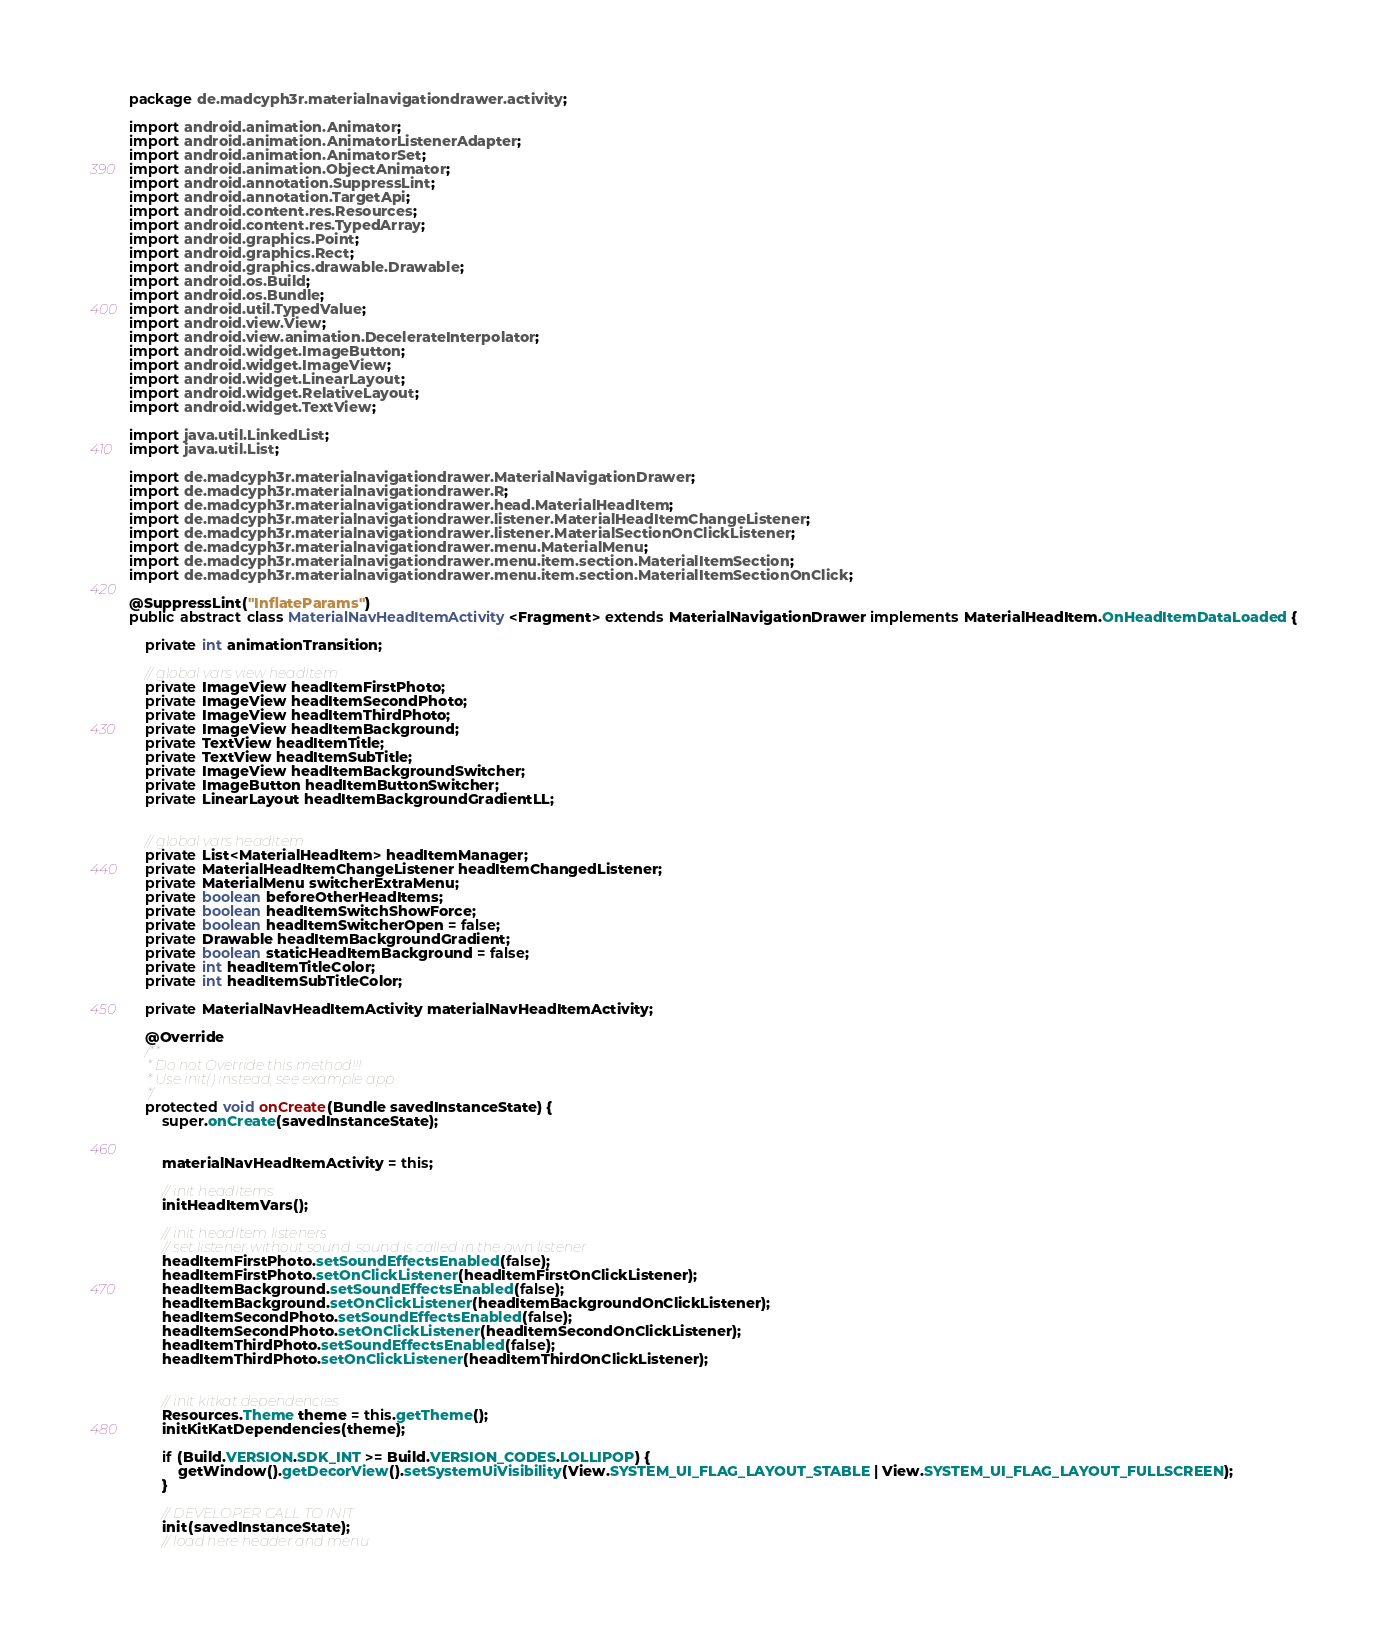<code> <loc_0><loc_0><loc_500><loc_500><_Java_>package de.madcyph3r.materialnavigationdrawer.activity;

import android.animation.Animator;
import android.animation.AnimatorListenerAdapter;
import android.animation.AnimatorSet;
import android.animation.ObjectAnimator;
import android.annotation.SuppressLint;
import android.annotation.TargetApi;
import android.content.res.Resources;
import android.content.res.TypedArray;
import android.graphics.Point;
import android.graphics.Rect;
import android.graphics.drawable.Drawable;
import android.os.Build;
import android.os.Bundle;
import android.util.TypedValue;
import android.view.View;
import android.view.animation.DecelerateInterpolator;
import android.widget.ImageButton;
import android.widget.ImageView;
import android.widget.LinearLayout;
import android.widget.RelativeLayout;
import android.widget.TextView;

import java.util.LinkedList;
import java.util.List;

import de.madcyph3r.materialnavigationdrawer.MaterialNavigationDrawer;
import de.madcyph3r.materialnavigationdrawer.R;
import de.madcyph3r.materialnavigationdrawer.head.MaterialHeadItem;
import de.madcyph3r.materialnavigationdrawer.listener.MaterialHeadItemChangeListener;
import de.madcyph3r.materialnavigationdrawer.listener.MaterialSectionOnClickListener;
import de.madcyph3r.materialnavigationdrawer.menu.MaterialMenu;
import de.madcyph3r.materialnavigationdrawer.menu.item.section.MaterialItemSection;
import de.madcyph3r.materialnavigationdrawer.menu.item.section.MaterialItemSectionOnClick;

@SuppressLint("InflateParams")
public abstract class MaterialNavHeadItemActivity<Fragment> extends MaterialNavigationDrawer implements MaterialHeadItem.OnHeadItemDataLoaded {

    private int animationTransition;

    // global vars view headItem
    private ImageView headItemFirstPhoto;
    private ImageView headItemSecondPhoto;
    private ImageView headItemThirdPhoto;
    private ImageView headItemBackground;
    private TextView headItemTitle;
    private TextView headItemSubTitle;
    private ImageView headItemBackgroundSwitcher;
    private ImageButton headItemButtonSwitcher;
    private LinearLayout headItemBackgroundGradientLL;


    // global vars headItem
    private List<MaterialHeadItem> headItemManager;
    private MaterialHeadItemChangeListener headItemChangedListener;
    private MaterialMenu switcherExtraMenu;
    private boolean beforeOtherHeadItems;
    private boolean headItemSwitchShowForce;
    private boolean headItemSwitcherOpen = false;
    private Drawable headItemBackgroundGradient;
    private boolean staticHeadItemBackground = false;
    private int headItemTitleColor;
    private int headItemSubTitleColor;

    private MaterialNavHeadItemActivity materialNavHeadItemActivity;

    @Override
    /**
     * Do not Override this method!!!
     * Use init() instead, see example app
     */
    protected void onCreate(Bundle savedInstanceState) {
        super.onCreate(savedInstanceState);


        materialNavHeadItemActivity = this;

        // init headItems
        initHeadItemVars();

        // init headItem listeners
        // set listener without sound. sound is called in the own listener
        headItemFirstPhoto.setSoundEffectsEnabled(false);
        headItemFirstPhoto.setOnClickListener(headItemFirstOnClickListener);
        headItemBackground.setSoundEffectsEnabled(false);
        headItemBackground.setOnClickListener(headItemBackgroundOnClickListener);
        headItemSecondPhoto.setSoundEffectsEnabled(false);
        headItemSecondPhoto.setOnClickListener(headItemSecondOnClickListener);
        headItemThirdPhoto.setSoundEffectsEnabled(false);
        headItemThirdPhoto.setOnClickListener(headItemThirdOnClickListener);


        // init kitkat dependencies
        Resources.Theme theme = this.getTheme();
        initKitKatDependencies(theme);

        if (Build.VERSION.SDK_INT >= Build.VERSION_CODES.LOLLIPOP) {
            getWindow().getDecorView().setSystemUiVisibility(View.SYSTEM_UI_FLAG_LAYOUT_STABLE | View.SYSTEM_UI_FLAG_LAYOUT_FULLSCREEN);
        }

        // DEVELOPER CALL TO INIT
        init(savedInstanceState);
        // load here header and menu</code> 